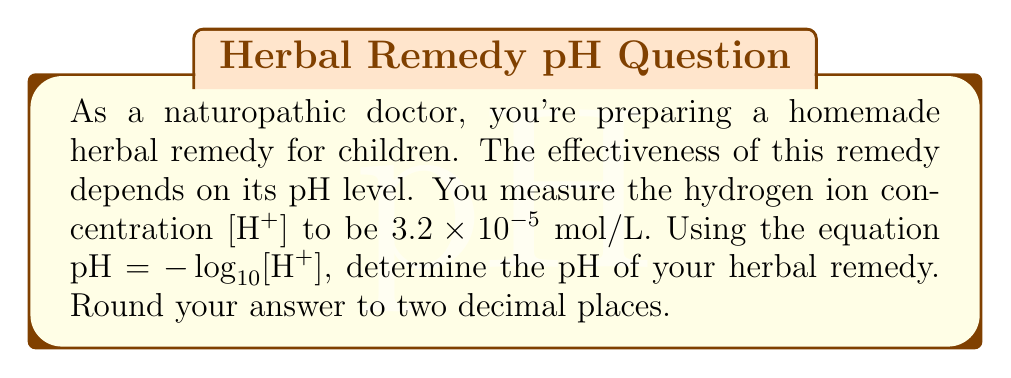Teach me how to tackle this problem. To solve this problem, we'll use the given equation and the hydrogen ion concentration:

1) The equation for pH is:
   $pH = -\log_{10}[H^+]$

2) We're given that $[H^+] = 3.2 \times 10^{-5}$ mol/L

3) Let's substitute this into our equation:
   $pH = -\log_{10}(3.2 \times 10^{-5})$

4) Now we can evaluate this using the properties of logarithms:
   $pH = -(\log_{10}3.2 + \log_{10}10^{-5})$
   $pH = -(0.5051 - 5)$
   $pH = -(-4.4949)$
   $pH = 4.4949$

5) Rounding to two decimal places:
   $pH = 4.49$

This pH indicates that the herbal remedy is acidic, as it's below 7 on the pH scale.
Answer: 4.49 